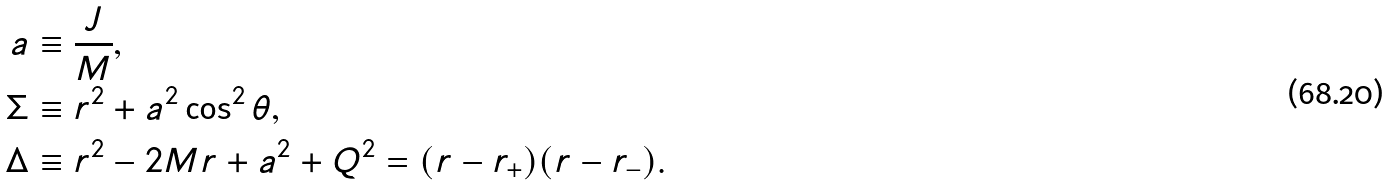<formula> <loc_0><loc_0><loc_500><loc_500>a & \equiv \frac { J } { M } , \\ \Sigma & \equiv r ^ { 2 } + a ^ { 2 } \cos ^ { 2 } \theta , \\ \Delta & \equiv r ^ { 2 } - 2 M r + a ^ { 2 } + Q ^ { 2 } = ( r - r _ { + } ) ( r - r _ { - } ) .</formula> 